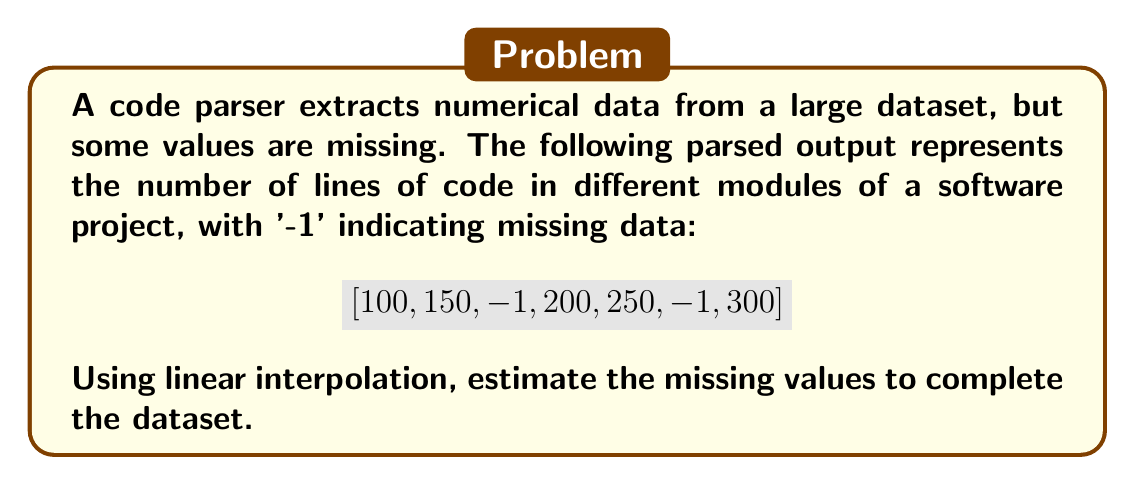Show me your answer to this math problem. To solve this problem using linear interpolation, we'll follow these steps:

1) Identify the positions of missing data (represented by -1):
   - Index 2 and Index 5 have missing values

2) For each missing value, we'll use the nearest known values before and after:
   - For index 2: Use values at index 1 (150) and index 3 (200)
   - For index 5: Use values at index 4 (250) and index 6 (300)

3) Apply linear interpolation formula:
   $$y = y_1 + \frac{x - x_1}{x_2 - x_1}(y_2 - y_1)$$
   where $(x_1, y_1)$ and $(x_2, y_2)$ are known points, and $(x, y)$ is the point we're interpolating.

4) For index 2:
   $x_1 = 1, y_1 = 150, x_2 = 3, y_2 = 200, x = 2$
   $$y = 150 + \frac{2 - 1}{3 - 1}(200 - 150) = 150 + 25 = 175$$

5) For index 5:
   $x_1 = 4, y_1 = 250, x_2 = 6, y_2 = 300, x = 5$
   $$y = 250 + \frac{5 - 4}{6 - 4}(300 - 250) = 250 + 25 = 275$$

6) Replace the -1 values in the original array with these interpolated values.
Answer: $[100, 150, 175, 200, 250, 275, 300]$ 